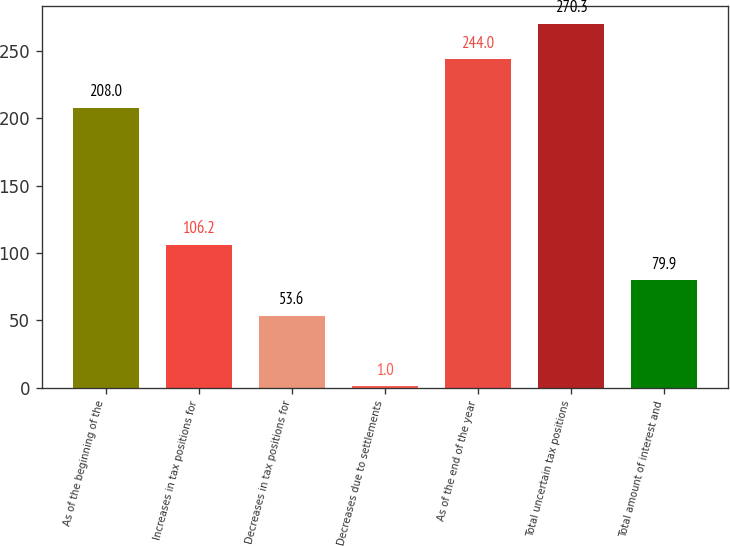<chart> <loc_0><loc_0><loc_500><loc_500><bar_chart><fcel>As of the beginning of the<fcel>Increases in tax positions for<fcel>Decreases in tax positions for<fcel>Decreases due to settlements<fcel>As of the end of the year<fcel>Total uncertain tax positions<fcel>Total amount of interest and<nl><fcel>208<fcel>106.2<fcel>53.6<fcel>1<fcel>244<fcel>270.3<fcel>79.9<nl></chart> 